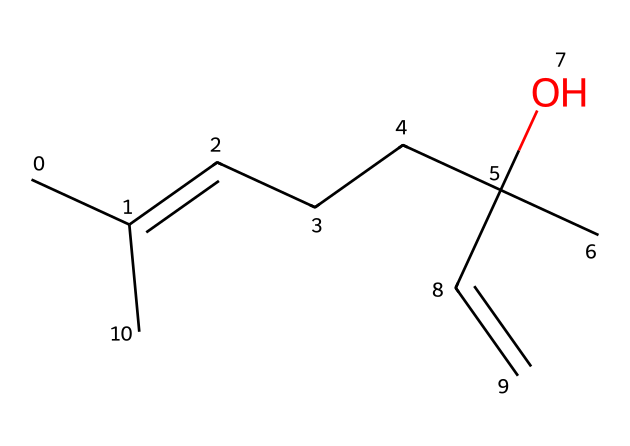How many carbon atoms are in linalool? By analyzing the provided SMILES representation, there are eight carbon atoms present in the structure, which can be counted from the carbon symbols (C) in the formula.
Answer: eight What is the functional group present in linalool? The SMILES indicates the presence of an alcohol functional group due to the hydroxy (–OH) part present in the structure.
Answer: alcohol How many double bonds are there in linalool? Upon examining the structure based on the SMILES notation, there are two double bonds indicated in the carbon chain structure (noted by the '=' signs in the representation).
Answer: two What type of compound is linalool classified as? Linalool is a monoterpenoid compound, characterized by having a specific structure formed from two isoprene units.
Answer: monoterpenoid Which part of linalool contributes to its floral scent? The specific arrangement of carbon and the presence of the double bonds gives linalool its characteristic floral aroma, particularly the configuration around the unsaturated bonds.
Answer: configuration around unsaturated bonds In what type of products is linalool commonly used? Linalool is widely used in perfumes, soaps, and other fragrance products due to its pleasant scent profile.
Answer: perfumes 